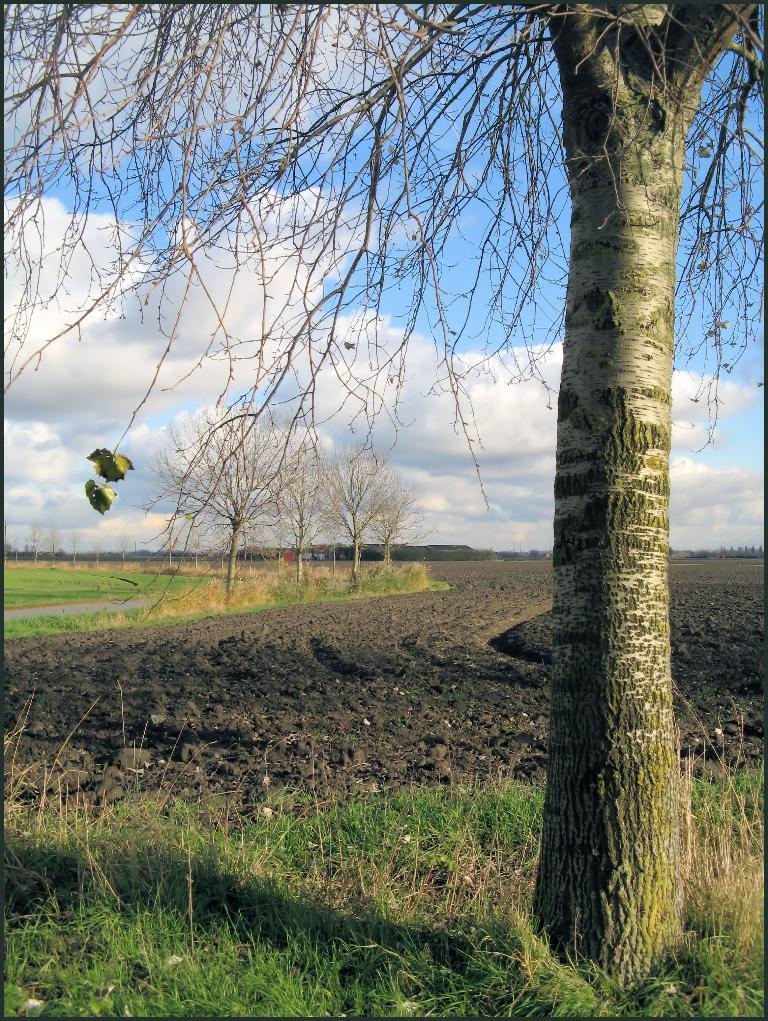What type of vegetation can be seen on the right side of the image? There is a tree on the right side of the image. What can be seen in the background of the image? The sky, clouds, trees, grass, and mud are visible in the background of the image. What is the size of the spark in the image? There is no spark present in the image. Can you tell me how the trees in the background are talking to each other? Trees do not have the ability to talk, so this cannot be observed in the image. 